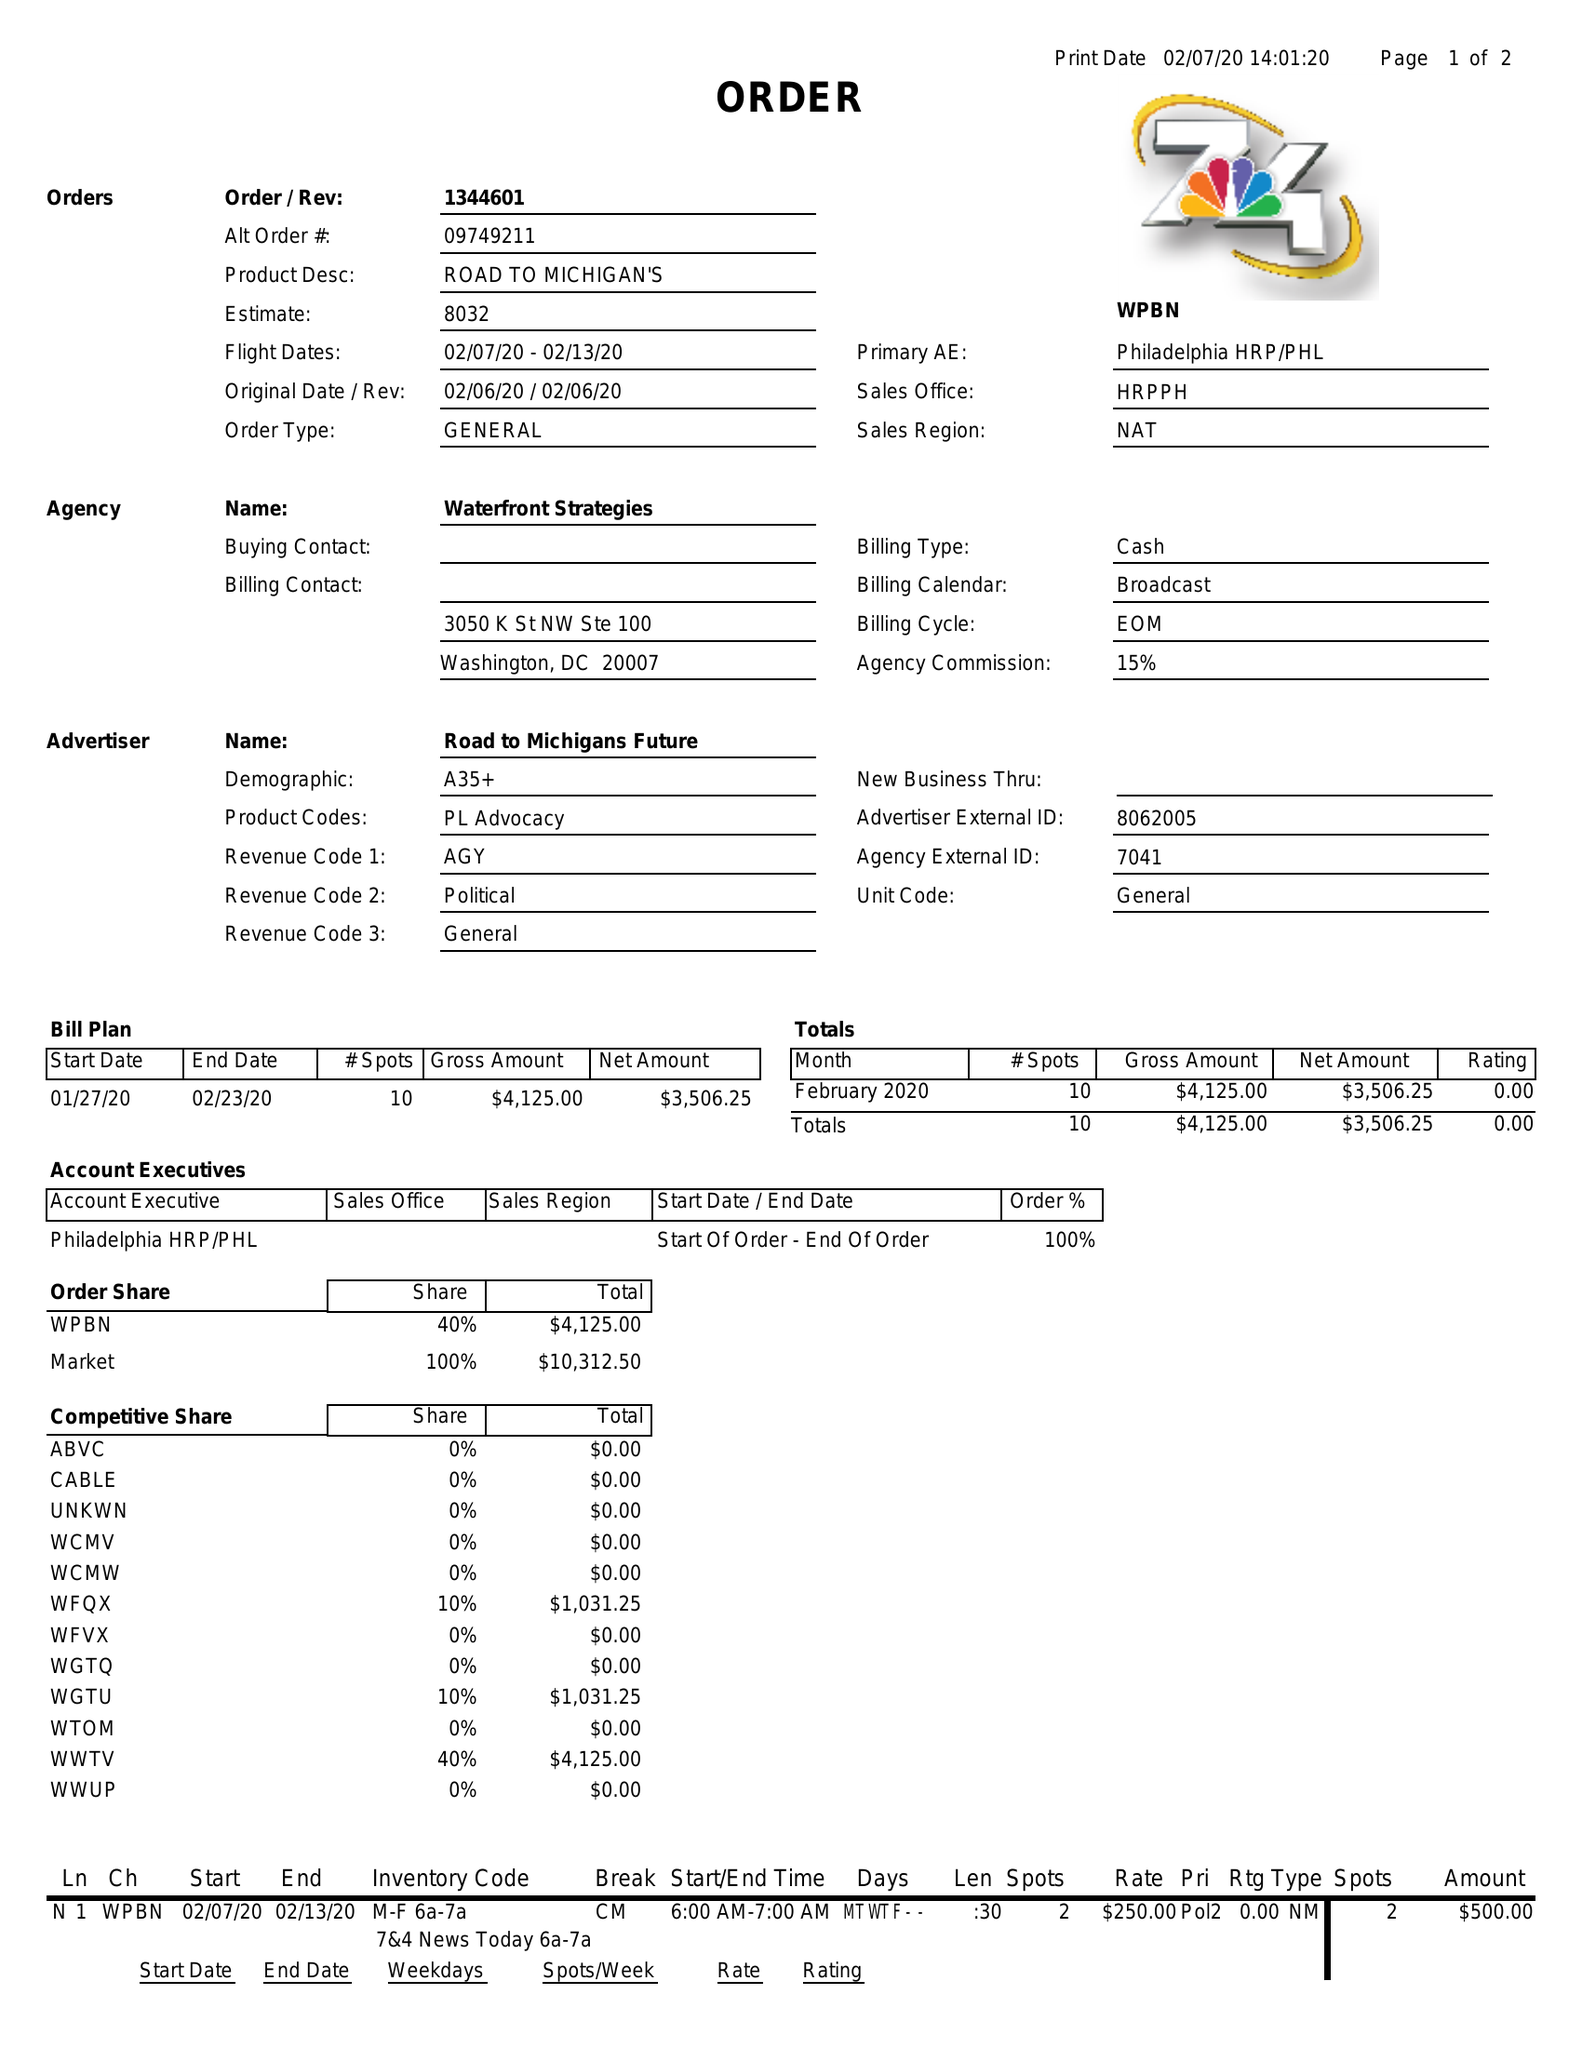What is the value for the gross_amount?
Answer the question using a single word or phrase. 4125.00 